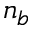<formula> <loc_0><loc_0><loc_500><loc_500>n _ { b }</formula> 